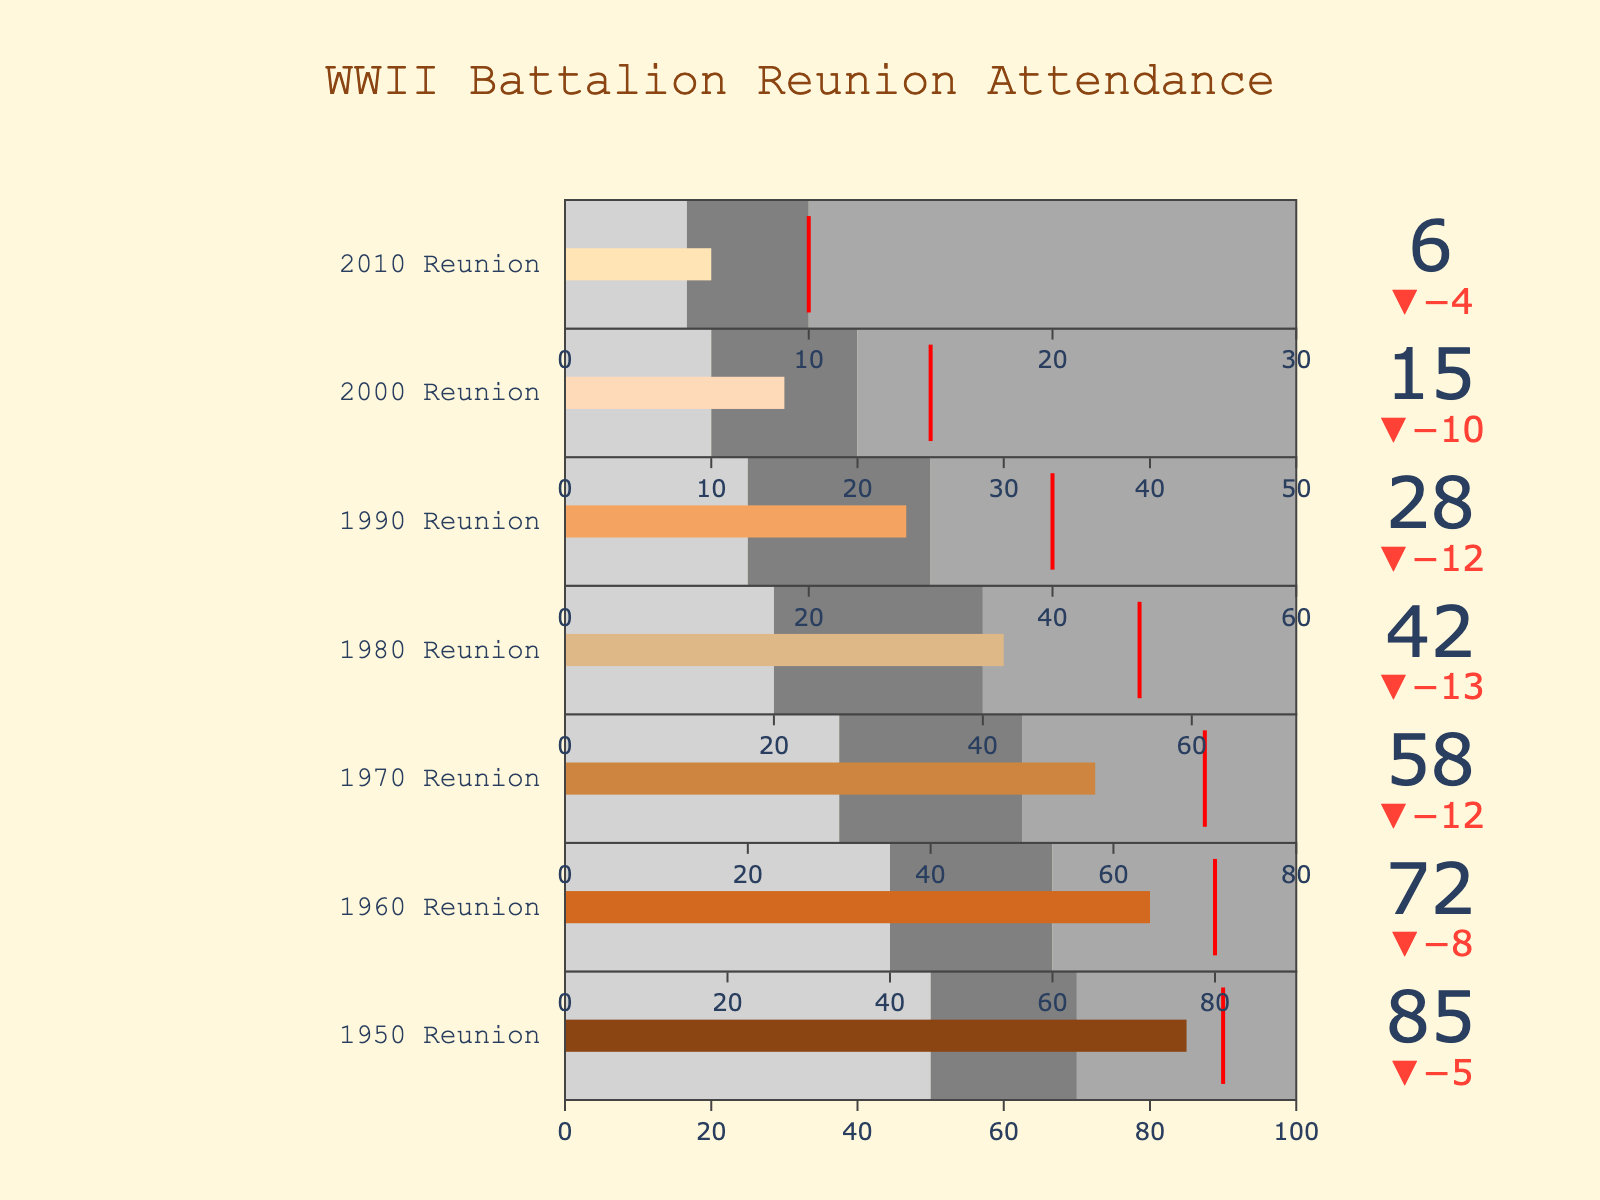Did actual attendance at the 1950 Reunion meet the target? Looking at the 1950 Reunion, the actual attendance is 85. The target is 90. Since 85 is less than 90, the actual attendance did not meet the target.
Answer: No Which reunion year had the highest actual attendance? To find the reunion year with the highest actual attendance, compare the 'Actual' column for all years. The 1950 Reunion has the highest value with an actual attendance of 85.
Answer: 1950 Reunion What is the difference between actual and target attendance for the 1980 Reunion? To find the difference, subtract the actual attendance from the target attendance for the 1980 Reunion: 55 - 42 = 13.
Answer: 13 How did the 2010 Reunion's actual attendance compare to its target? The 2010 Reunion had an actual attendance of 6 and a target attendance of 10. Since 6 is less than 10, the actual attendance was below the target.
Answer: Below target Which reunion year has the smallest difference between actual and target attendance? Calculate the difference for each year: 
1950 (90 - 85 = 5), 
1960 (80 - 72 = 8), 
1970 (70 - 58 = 12), 
1980 (55 - 42 = 13), 
1990 (40 - 28 = 12), 
2000 (25 - 15 = 10), 
2010 (10 - 6 = 4). 
The smallest difference is 4 for the 2010 Reunion.
Answer: 2010 Reunion What trend can be observed in the actual attendance over the decades? By examining the 'Actual' column over the years from 1950 to 2010, it is observable that the actual attendance has been decreasing over the decades.
Answer: Decreasing Which reunion had the highest level of attendee participation relative to target attendance? To determine the highest relative participation, calculate the ratio of actual attendance to target attendance for each reunion and compare:
1950: 85/90 = 0.94,
1960: 72/80 = 0.9,
1970: 58/70 = 0.83,
1980: 42/55 = 0.76,
1990: 28/40 = 0.7,
2000: 15/25 = 0.6,
2010: 6/10 = 0.6.
The 1950 Reunion has the highest ratio of 0.94.
Answer: 1950 Reunion What can you infer about the participation rate for the 2000 Reunion based on the ranges? The participation ranges are 10-20 (lightgray), 20-50 (gray), and above (darkgray). The actual attendance (15) falls in the lightgray range, just slightly above the minimum (10), indicating low participation.
Answer: Low participation Which reunion year saw a significant drop in actual attendance compared to the previous one? Compare the differences between consecutive years: 
1950-1960: 85 - 72 = 13, 
1960-1970: 72 - 58 = 14, 
1970-1980: 58 - 42 = 16, 
1980-1990: 42 - 28 = 14, 
1990-2000: 28 - 15 = 13, 
2000-2010: 15 - 6 = 9.
The 1970-1980 period saw the highest drop of 16.
Answer: 1970-1980 Is there any reunion year where the actual attendance exceeds any range beyond the first? Look at each year's 'Actual' value and compare it to the ranges:
1950 (actual: 85, range2: 70),
1960 (actual: 72, range2: 60),
1970 (actual: 58, range2: 50), 
1980 (actual: 42, range2: 40),
1990 (actual: 28, range2: 30), 
2000 (actual: 15, range2: 20), 
2010 (actual: 6, range2: 10). 
All years except 1990 exceed the first range.
Answer: Yes, all except 1990 